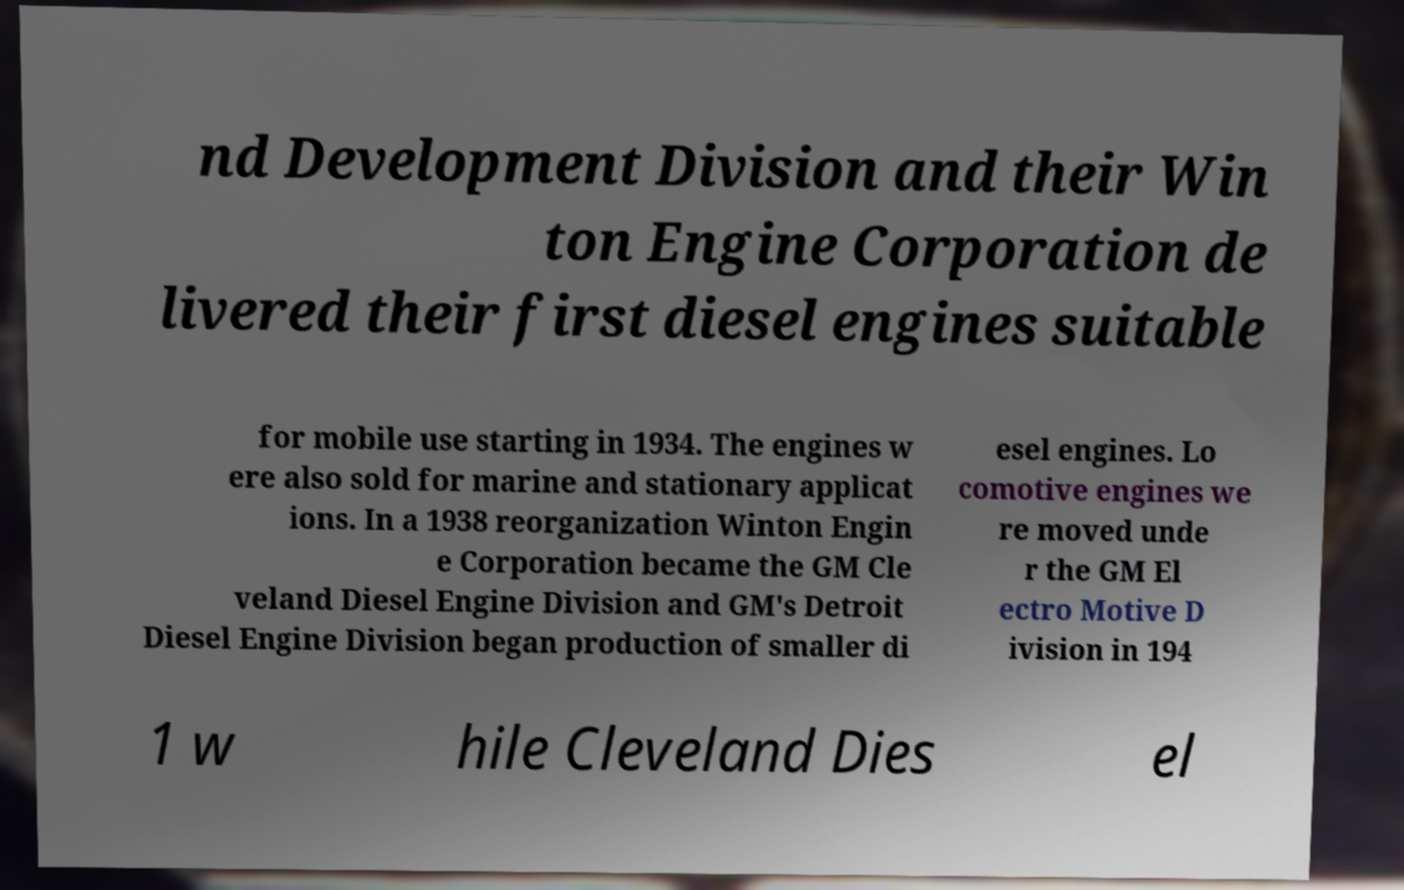For documentation purposes, I need the text within this image transcribed. Could you provide that? nd Development Division and their Win ton Engine Corporation de livered their first diesel engines suitable for mobile use starting in 1934. The engines w ere also sold for marine and stationary applicat ions. In a 1938 reorganization Winton Engin e Corporation became the GM Cle veland Diesel Engine Division and GM's Detroit Diesel Engine Division began production of smaller di esel engines. Lo comotive engines we re moved unde r the GM El ectro Motive D ivision in 194 1 w hile Cleveland Dies el 